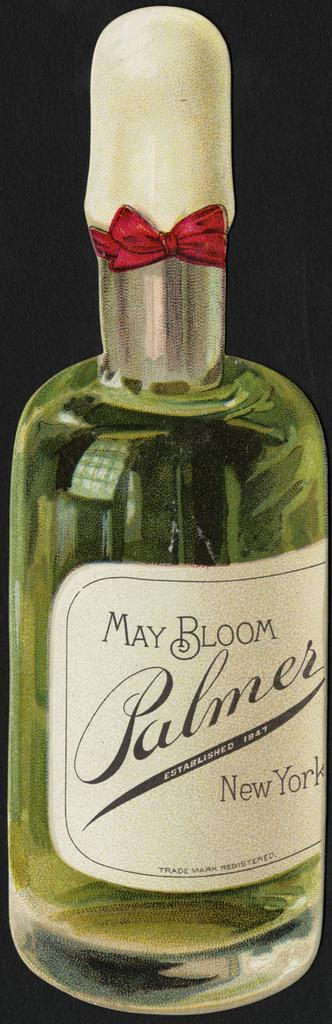<image>
Render a clear and concise summary of the photo. a new bottle of may bloom plamer new york 